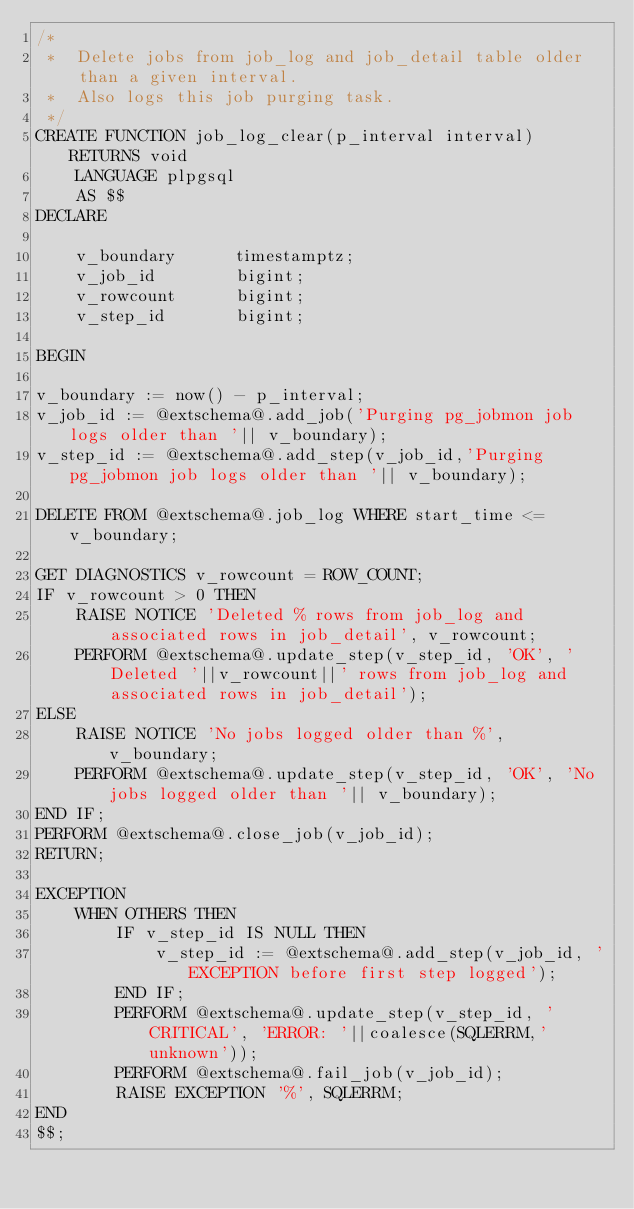<code> <loc_0><loc_0><loc_500><loc_500><_SQL_>/*
 *  Delete jobs from job_log and job_detail table older than a given interval.
 *  Also logs this job purging task.
 */
CREATE FUNCTION job_log_clear(p_interval interval) RETURNS void
    LANGUAGE plpgsql
    AS $$
DECLARE
    
    v_boundary      timestamptz;
    v_job_id        bigint;
    v_rowcount      bigint;
    v_step_id       bigint;

BEGIN

v_boundary := now() - p_interval;
v_job_id := @extschema@.add_job('Purging pg_jobmon job logs older than '|| v_boundary);
v_step_id := @extschema@.add_step(v_job_id,'Purging pg_jobmon job logs older than '|| v_boundary);

DELETE FROM @extschema@.job_log WHERE start_time <= v_boundary;

GET DIAGNOSTICS v_rowcount = ROW_COUNT;
IF v_rowcount > 0 THEN
    RAISE NOTICE 'Deleted % rows from job_log and associated rows in job_detail', v_rowcount;
    PERFORM @extschema@.update_step(v_step_id, 'OK', 'Deleted '||v_rowcount||' rows from job_log and associated rows in job_detail');
ELSE
    RAISE NOTICE 'No jobs logged older than %', v_boundary;
    PERFORM @extschema@.update_step(v_step_id, 'OK', 'No jobs logged older than '|| v_boundary);
END IF;
PERFORM @extschema@.close_job(v_job_id);
RETURN;

EXCEPTION
    WHEN OTHERS THEN
        IF v_step_id IS NULL THEN
            v_step_id := @extschema@.add_step(v_job_id, 'EXCEPTION before first step logged');
        END IF;
        PERFORM @extschema@.update_step(v_step_id, 'CRITICAL', 'ERROR: '||coalesce(SQLERRM,'unknown'));
        PERFORM @extschema@.fail_job(v_job_id);
        RAISE EXCEPTION '%', SQLERRM;
END
$$;
</code> 